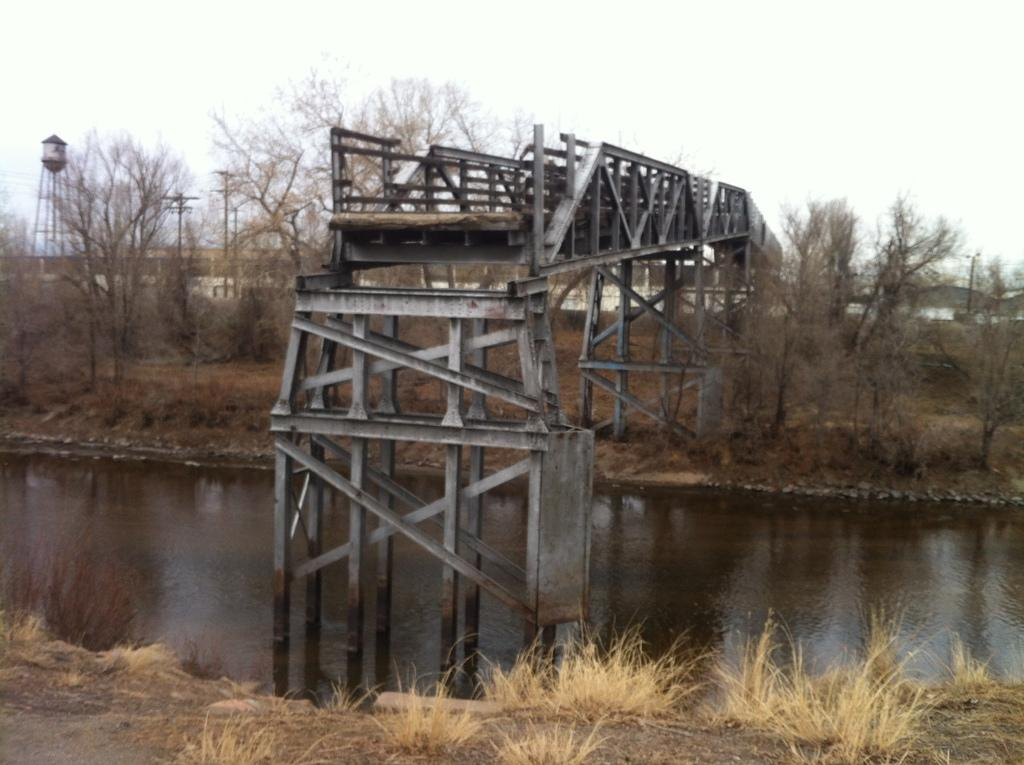What type of vegetation is present in the image? There is grass in the image. What natural element is also present in the image? There is water in the image. What other natural elements can be seen in the image? There are trees in the image. What man-made structure is present in the image? There is a bridge in the image. What other man-made structures can be seen in the background? In the background, there are poles, a tower, and buildings. What part of the natural environment is visible in the background? The sky is visible in the background. What type of country is depicted in the image? The image does not depict a specific country; it shows a natural and man-made landscape. What team is playing in the image? There is no team or sporting event depicted in the image. 